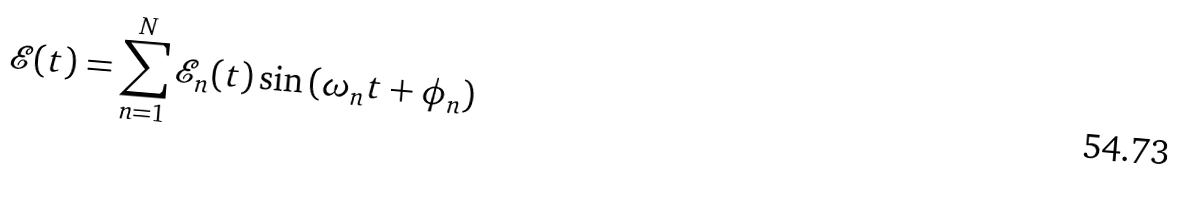Convert formula to latex. <formula><loc_0><loc_0><loc_500><loc_500>\mathcal { E } ( t ) = \sum _ { n = 1 } ^ { N } \mathcal { E } _ { n } ( t ) \sin \left ( \omega _ { n } t + \phi _ { n } \right )</formula> 